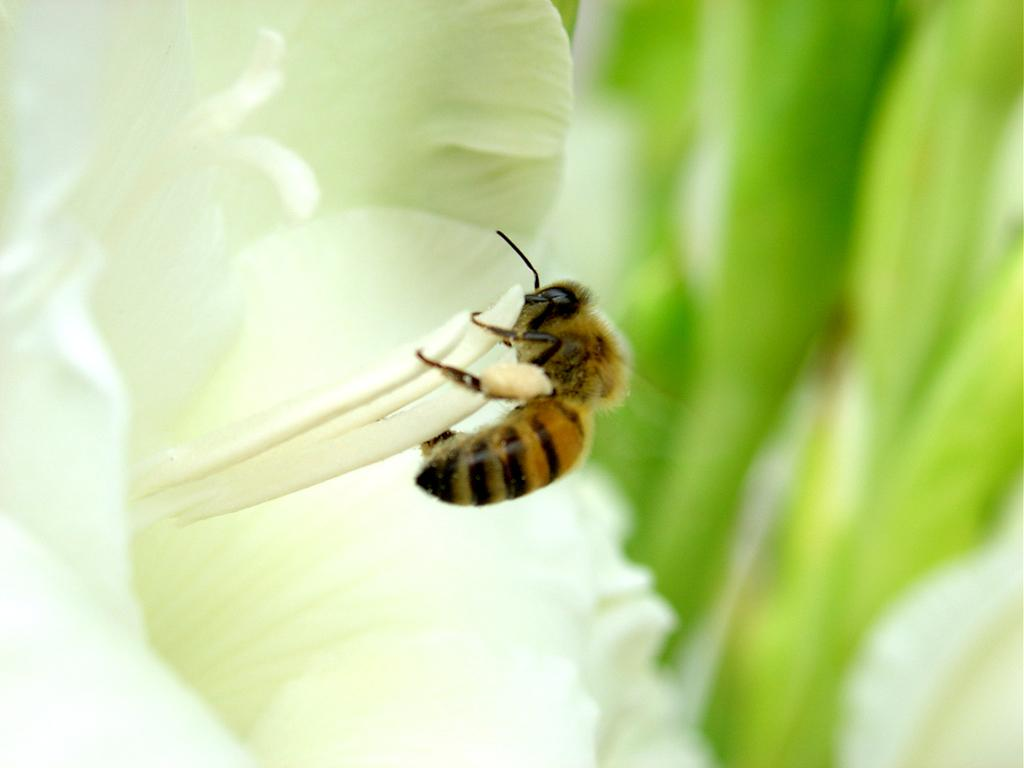What insect is present in the image? There is a bee in the image. What is the bee doing in the image? The bee is on a white flower. Can you describe the background of the image? The background of the image is blurred. What letter can be seen on the wrench in the image? There is no wrench or letter present in the image; it features a bee on a white flower with a blurred background. 